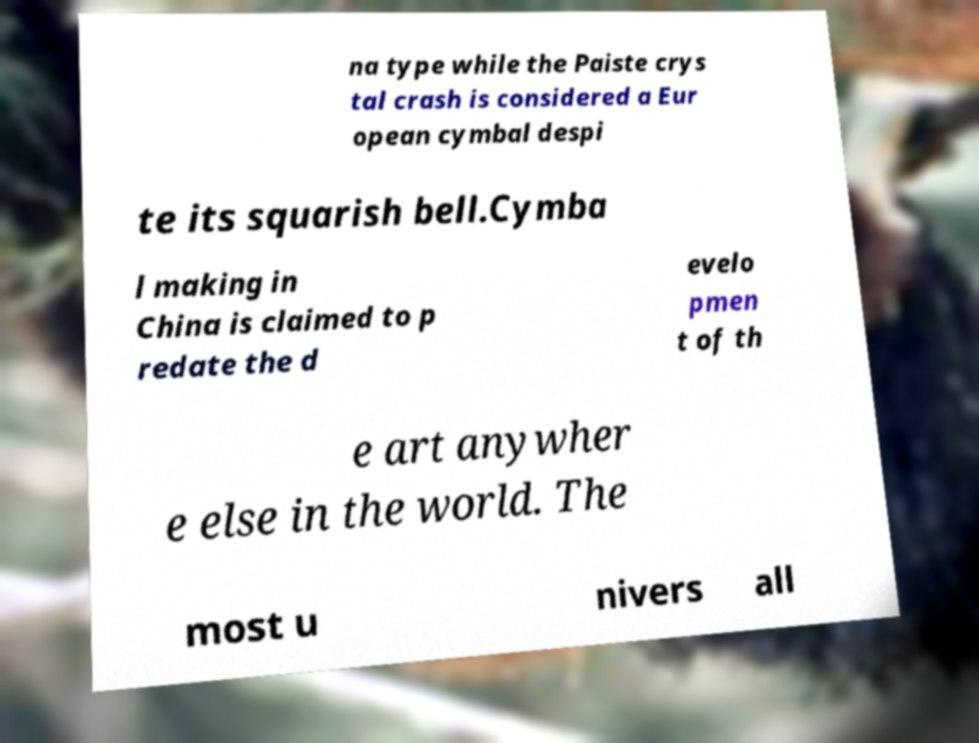For documentation purposes, I need the text within this image transcribed. Could you provide that? na type while the Paiste crys tal crash is considered a Eur opean cymbal despi te its squarish bell.Cymba l making in China is claimed to p redate the d evelo pmen t of th e art anywher e else in the world. The most u nivers all 